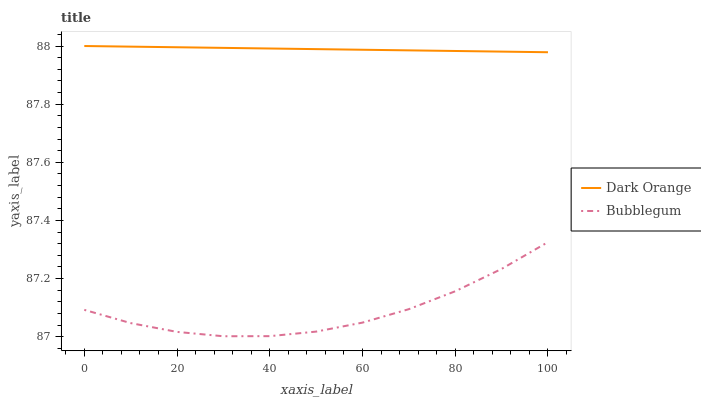Does Bubblegum have the minimum area under the curve?
Answer yes or no. Yes. Does Dark Orange have the maximum area under the curve?
Answer yes or no. Yes. Does Bubblegum have the maximum area under the curve?
Answer yes or no. No. Is Dark Orange the smoothest?
Answer yes or no. Yes. Is Bubblegum the roughest?
Answer yes or no. Yes. Is Bubblegum the smoothest?
Answer yes or no. No. Does Bubblegum have the highest value?
Answer yes or no. No. Is Bubblegum less than Dark Orange?
Answer yes or no. Yes. Is Dark Orange greater than Bubblegum?
Answer yes or no. Yes. Does Bubblegum intersect Dark Orange?
Answer yes or no. No. 